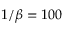<formula> <loc_0><loc_0><loc_500><loc_500>1 / \beta = 1 0 0</formula> 